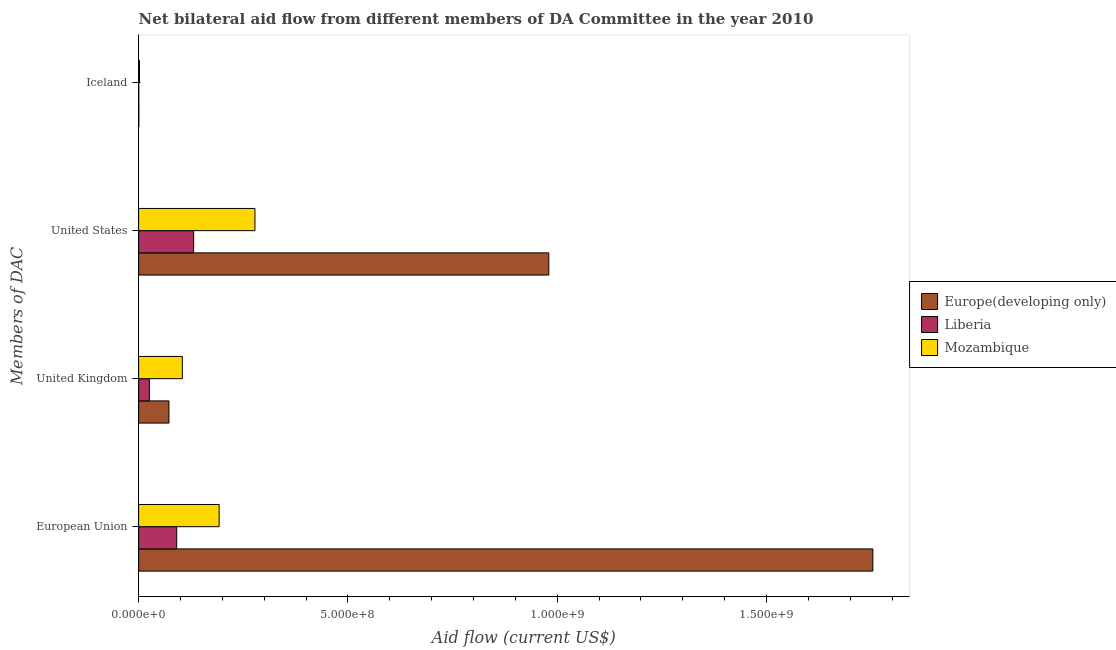How many groups of bars are there?
Provide a succinct answer. 4. Are the number of bars per tick equal to the number of legend labels?
Your answer should be very brief. Yes. What is the label of the 4th group of bars from the top?
Offer a very short reply. European Union. What is the amount of aid given by iceland in Liberia?
Your response must be concise. 3.50e+05. Across all countries, what is the maximum amount of aid given by us?
Offer a terse response. 9.80e+08. Across all countries, what is the minimum amount of aid given by eu?
Make the answer very short. 9.09e+07. In which country was the amount of aid given by uk maximum?
Provide a succinct answer. Mozambique. In which country was the amount of aid given by uk minimum?
Give a very brief answer. Liberia. What is the total amount of aid given by uk in the graph?
Ensure brevity in your answer.  2.02e+08. What is the difference between the amount of aid given by uk in Liberia and that in Mozambique?
Provide a short and direct response. -7.88e+07. What is the difference between the amount of aid given by us in Europe(developing only) and the amount of aid given by eu in Liberia?
Provide a succinct answer. 8.89e+08. What is the average amount of aid given by us per country?
Keep it short and to the point. 4.63e+08. What is the difference between the amount of aid given by us and amount of aid given by iceland in Liberia?
Offer a very short reply. 1.31e+08. What is the ratio of the amount of aid given by us in Liberia to that in Europe(developing only)?
Your answer should be very brief. 0.13. What is the difference between the highest and the second highest amount of aid given by eu?
Your response must be concise. 1.56e+09. What is the difference between the highest and the lowest amount of aid given by uk?
Your answer should be compact. 7.88e+07. Is the sum of the amount of aid given by iceland in Europe(developing only) and Liberia greater than the maximum amount of aid given by uk across all countries?
Provide a succinct answer. No. Is it the case that in every country, the sum of the amount of aid given by iceland and amount of aid given by eu is greater than the sum of amount of aid given by us and amount of aid given by uk?
Your response must be concise. No. What does the 3rd bar from the top in United Kingdom represents?
Your answer should be very brief. Europe(developing only). What does the 2nd bar from the bottom in United Kingdom represents?
Keep it short and to the point. Liberia. Is it the case that in every country, the sum of the amount of aid given by eu and amount of aid given by uk is greater than the amount of aid given by us?
Make the answer very short. No. How many bars are there?
Your answer should be very brief. 12. Are all the bars in the graph horizontal?
Provide a succinct answer. Yes. How many countries are there in the graph?
Your answer should be very brief. 3. Does the graph contain any zero values?
Make the answer very short. No. Does the graph contain grids?
Make the answer very short. No. Where does the legend appear in the graph?
Make the answer very short. Center right. How are the legend labels stacked?
Your answer should be compact. Vertical. What is the title of the graph?
Keep it short and to the point. Net bilateral aid flow from different members of DA Committee in the year 2010. Does "Bosnia and Herzegovina" appear as one of the legend labels in the graph?
Your answer should be very brief. No. What is the label or title of the Y-axis?
Offer a very short reply. Members of DAC. What is the Aid flow (current US$) in Europe(developing only) in European Union?
Give a very brief answer. 1.75e+09. What is the Aid flow (current US$) in Liberia in European Union?
Offer a very short reply. 9.09e+07. What is the Aid flow (current US$) in Mozambique in European Union?
Your answer should be very brief. 1.92e+08. What is the Aid flow (current US$) of Europe(developing only) in United Kingdom?
Provide a short and direct response. 7.25e+07. What is the Aid flow (current US$) of Liberia in United Kingdom?
Your answer should be compact. 2.56e+07. What is the Aid flow (current US$) in Mozambique in United Kingdom?
Offer a very short reply. 1.04e+08. What is the Aid flow (current US$) of Europe(developing only) in United States?
Make the answer very short. 9.80e+08. What is the Aid flow (current US$) of Liberia in United States?
Ensure brevity in your answer.  1.31e+08. What is the Aid flow (current US$) of Mozambique in United States?
Provide a short and direct response. 2.78e+08. What is the Aid flow (current US$) in Europe(developing only) in Iceland?
Ensure brevity in your answer.  5.50e+05. What is the Aid flow (current US$) of Liberia in Iceland?
Your answer should be very brief. 3.50e+05. What is the Aid flow (current US$) of Mozambique in Iceland?
Give a very brief answer. 1.99e+06. Across all Members of DAC, what is the maximum Aid flow (current US$) in Europe(developing only)?
Ensure brevity in your answer.  1.75e+09. Across all Members of DAC, what is the maximum Aid flow (current US$) of Liberia?
Offer a very short reply. 1.31e+08. Across all Members of DAC, what is the maximum Aid flow (current US$) in Mozambique?
Offer a very short reply. 2.78e+08. Across all Members of DAC, what is the minimum Aid flow (current US$) of Europe(developing only)?
Your answer should be very brief. 5.50e+05. Across all Members of DAC, what is the minimum Aid flow (current US$) of Liberia?
Provide a succinct answer. 3.50e+05. Across all Members of DAC, what is the minimum Aid flow (current US$) of Mozambique?
Make the answer very short. 1.99e+06. What is the total Aid flow (current US$) in Europe(developing only) in the graph?
Ensure brevity in your answer.  2.81e+09. What is the total Aid flow (current US$) in Liberia in the graph?
Offer a very short reply. 2.48e+08. What is the total Aid flow (current US$) in Mozambique in the graph?
Make the answer very short. 5.77e+08. What is the difference between the Aid flow (current US$) of Europe(developing only) in European Union and that in United Kingdom?
Offer a very short reply. 1.68e+09. What is the difference between the Aid flow (current US$) of Liberia in European Union and that in United Kingdom?
Provide a short and direct response. 6.53e+07. What is the difference between the Aid flow (current US$) of Mozambique in European Union and that in United Kingdom?
Give a very brief answer. 8.79e+07. What is the difference between the Aid flow (current US$) in Europe(developing only) in European Union and that in United States?
Provide a succinct answer. 7.74e+08. What is the difference between the Aid flow (current US$) of Liberia in European Union and that in United States?
Offer a very short reply. -4.04e+07. What is the difference between the Aid flow (current US$) of Mozambique in European Union and that in United States?
Make the answer very short. -8.56e+07. What is the difference between the Aid flow (current US$) in Europe(developing only) in European Union and that in Iceland?
Provide a succinct answer. 1.75e+09. What is the difference between the Aid flow (current US$) of Liberia in European Union and that in Iceland?
Offer a very short reply. 9.06e+07. What is the difference between the Aid flow (current US$) of Mozambique in European Union and that in Iceland?
Give a very brief answer. 1.90e+08. What is the difference between the Aid flow (current US$) of Europe(developing only) in United Kingdom and that in United States?
Provide a succinct answer. -9.07e+08. What is the difference between the Aid flow (current US$) of Liberia in United Kingdom and that in United States?
Offer a very short reply. -1.06e+08. What is the difference between the Aid flow (current US$) of Mozambique in United Kingdom and that in United States?
Your answer should be compact. -1.73e+08. What is the difference between the Aid flow (current US$) of Europe(developing only) in United Kingdom and that in Iceland?
Your answer should be very brief. 7.19e+07. What is the difference between the Aid flow (current US$) of Liberia in United Kingdom and that in Iceland?
Provide a short and direct response. 2.52e+07. What is the difference between the Aid flow (current US$) of Mozambique in United Kingdom and that in Iceland?
Ensure brevity in your answer.  1.02e+08. What is the difference between the Aid flow (current US$) in Europe(developing only) in United States and that in Iceland?
Your answer should be very brief. 9.79e+08. What is the difference between the Aid flow (current US$) in Liberia in United States and that in Iceland?
Make the answer very short. 1.31e+08. What is the difference between the Aid flow (current US$) of Mozambique in United States and that in Iceland?
Offer a very short reply. 2.76e+08. What is the difference between the Aid flow (current US$) of Europe(developing only) in European Union and the Aid flow (current US$) of Liberia in United Kingdom?
Your response must be concise. 1.73e+09. What is the difference between the Aid flow (current US$) of Europe(developing only) in European Union and the Aid flow (current US$) of Mozambique in United Kingdom?
Give a very brief answer. 1.65e+09. What is the difference between the Aid flow (current US$) in Liberia in European Union and the Aid flow (current US$) in Mozambique in United Kingdom?
Offer a very short reply. -1.35e+07. What is the difference between the Aid flow (current US$) of Europe(developing only) in European Union and the Aid flow (current US$) of Liberia in United States?
Offer a very short reply. 1.62e+09. What is the difference between the Aid flow (current US$) of Europe(developing only) in European Union and the Aid flow (current US$) of Mozambique in United States?
Keep it short and to the point. 1.48e+09. What is the difference between the Aid flow (current US$) of Liberia in European Union and the Aid flow (current US$) of Mozambique in United States?
Keep it short and to the point. -1.87e+08. What is the difference between the Aid flow (current US$) in Europe(developing only) in European Union and the Aid flow (current US$) in Liberia in Iceland?
Your response must be concise. 1.75e+09. What is the difference between the Aid flow (current US$) of Europe(developing only) in European Union and the Aid flow (current US$) of Mozambique in Iceland?
Provide a succinct answer. 1.75e+09. What is the difference between the Aid flow (current US$) of Liberia in European Union and the Aid flow (current US$) of Mozambique in Iceland?
Give a very brief answer. 8.89e+07. What is the difference between the Aid flow (current US$) of Europe(developing only) in United Kingdom and the Aid flow (current US$) of Liberia in United States?
Keep it short and to the point. -5.89e+07. What is the difference between the Aid flow (current US$) of Europe(developing only) in United Kingdom and the Aid flow (current US$) of Mozambique in United States?
Provide a short and direct response. -2.05e+08. What is the difference between the Aid flow (current US$) in Liberia in United Kingdom and the Aid flow (current US$) in Mozambique in United States?
Give a very brief answer. -2.52e+08. What is the difference between the Aid flow (current US$) of Europe(developing only) in United Kingdom and the Aid flow (current US$) of Liberia in Iceland?
Provide a short and direct response. 7.21e+07. What is the difference between the Aid flow (current US$) in Europe(developing only) in United Kingdom and the Aid flow (current US$) in Mozambique in Iceland?
Make the answer very short. 7.05e+07. What is the difference between the Aid flow (current US$) in Liberia in United Kingdom and the Aid flow (current US$) in Mozambique in Iceland?
Provide a succinct answer. 2.36e+07. What is the difference between the Aid flow (current US$) of Europe(developing only) in United States and the Aid flow (current US$) of Liberia in Iceland?
Your answer should be compact. 9.80e+08. What is the difference between the Aid flow (current US$) of Europe(developing only) in United States and the Aid flow (current US$) of Mozambique in Iceland?
Give a very brief answer. 9.78e+08. What is the difference between the Aid flow (current US$) in Liberia in United States and the Aid flow (current US$) in Mozambique in Iceland?
Offer a very short reply. 1.29e+08. What is the average Aid flow (current US$) of Europe(developing only) per Members of DAC?
Your answer should be compact. 7.02e+08. What is the average Aid flow (current US$) of Liberia per Members of DAC?
Your response must be concise. 6.21e+07. What is the average Aid flow (current US$) of Mozambique per Members of DAC?
Make the answer very short. 1.44e+08. What is the difference between the Aid flow (current US$) in Europe(developing only) and Aid flow (current US$) in Liberia in European Union?
Give a very brief answer. 1.66e+09. What is the difference between the Aid flow (current US$) of Europe(developing only) and Aid flow (current US$) of Mozambique in European Union?
Your answer should be compact. 1.56e+09. What is the difference between the Aid flow (current US$) of Liberia and Aid flow (current US$) of Mozambique in European Union?
Offer a terse response. -1.01e+08. What is the difference between the Aid flow (current US$) of Europe(developing only) and Aid flow (current US$) of Liberia in United Kingdom?
Give a very brief answer. 4.69e+07. What is the difference between the Aid flow (current US$) in Europe(developing only) and Aid flow (current US$) in Mozambique in United Kingdom?
Ensure brevity in your answer.  -3.20e+07. What is the difference between the Aid flow (current US$) in Liberia and Aid flow (current US$) in Mozambique in United Kingdom?
Offer a very short reply. -7.88e+07. What is the difference between the Aid flow (current US$) of Europe(developing only) and Aid flow (current US$) of Liberia in United States?
Keep it short and to the point. 8.49e+08. What is the difference between the Aid flow (current US$) in Europe(developing only) and Aid flow (current US$) in Mozambique in United States?
Provide a short and direct response. 7.02e+08. What is the difference between the Aid flow (current US$) of Liberia and Aid flow (current US$) of Mozambique in United States?
Keep it short and to the point. -1.47e+08. What is the difference between the Aid flow (current US$) in Europe(developing only) and Aid flow (current US$) in Liberia in Iceland?
Your response must be concise. 2.00e+05. What is the difference between the Aid flow (current US$) of Europe(developing only) and Aid flow (current US$) of Mozambique in Iceland?
Make the answer very short. -1.44e+06. What is the difference between the Aid flow (current US$) in Liberia and Aid flow (current US$) in Mozambique in Iceland?
Ensure brevity in your answer.  -1.64e+06. What is the ratio of the Aid flow (current US$) in Europe(developing only) in European Union to that in United Kingdom?
Keep it short and to the point. 24.21. What is the ratio of the Aid flow (current US$) of Liberia in European Union to that in United Kingdom?
Make the answer very short. 3.55. What is the ratio of the Aid flow (current US$) in Mozambique in European Union to that in United Kingdom?
Keep it short and to the point. 1.84. What is the ratio of the Aid flow (current US$) of Europe(developing only) in European Union to that in United States?
Ensure brevity in your answer.  1.79. What is the ratio of the Aid flow (current US$) of Liberia in European Union to that in United States?
Ensure brevity in your answer.  0.69. What is the ratio of the Aid flow (current US$) in Mozambique in European Union to that in United States?
Offer a terse response. 0.69. What is the ratio of the Aid flow (current US$) in Europe(developing only) in European Union to that in Iceland?
Provide a short and direct response. 3189.18. What is the ratio of the Aid flow (current US$) in Liberia in European Union to that in Iceland?
Provide a short and direct response. 259.77. What is the ratio of the Aid flow (current US$) in Mozambique in European Union to that in Iceland?
Provide a short and direct response. 96.65. What is the ratio of the Aid flow (current US$) of Europe(developing only) in United Kingdom to that in United States?
Provide a short and direct response. 0.07. What is the ratio of the Aid flow (current US$) of Liberia in United Kingdom to that in United States?
Offer a terse response. 0.19. What is the ratio of the Aid flow (current US$) in Mozambique in United Kingdom to that in United States?
Offer a terse response. 0.38. What is the ratio of the Aid flow (current US$) in Europe(developing only) in United Kingdom to that in Iceland?
Give a very brief answer. 131.75. What is the ratio of the Aid flow (current US$) of Liberia in United Kingdom to that in Iceland?
Offer a terse response. 73.09. What is the ratio of the Aid flow (current US$) in Mozambique in United Kingdom to that in Iceland?
Your answer should be very brief. 52.47. What is the ratio of the Aid flow (current US$) of Europe(developing only) in United States to that in Iceland?
Your answer should be very brief. 1781.65. What is the ratio of the Aid flow (current US$) in Liberia in United States to that in Iceland?
Your response must be concise. 375.34. What is the ratio of the Aid flow (current US$) of Mozambique in United States to that in Iceland?
Your answer should be very brief. 139.65. What is the difference between the highest and the second highest Aid flow (current US$) of Europe(developing only)?
Your response must be concise. 7.74e+08. What is the difference between the highest and the second highest Aid flow (current US$) of Liberia?
Make the answer very short. 4.04e+07. What is the difference between the highest and the second highest Aid flow (current US$) in Mozambique?
Provide a short and direct response. 8.56e+07. What is the difference between the highest and the lowest Aid flow (current US$) in Europe(developing only)?
Make the answer very short. 1.75e+09. What is the difference between the highest and the lowest Aid flow (current US$) of Liberia?
Provide a short and direct response. 1.31e+08. What is the difference between the highest and the lowest Aid flow (current US$) in Mozambique?
Give a very brief answer. 2.76e+08. 